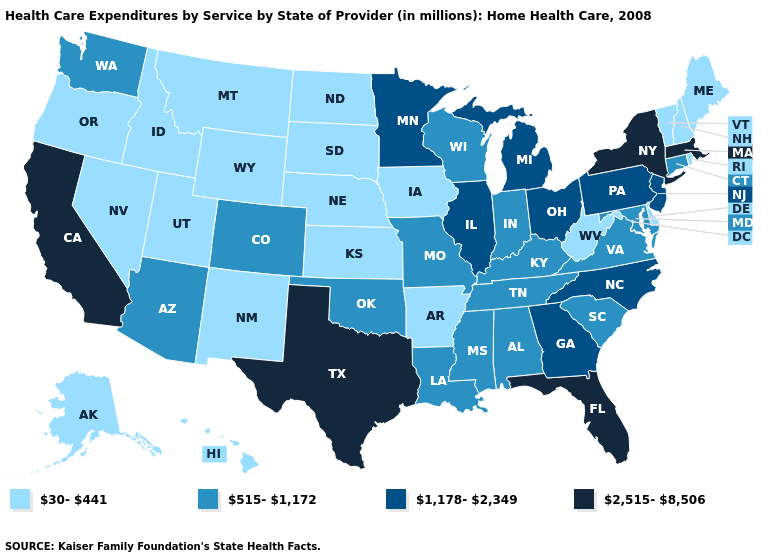Name the states that have a value in the range 515-1,172?
Be succinct. Alabama, Arizona, Colorado, Connecticut, Indiana, Kentucky, Louisiana, Maryland, Mississippi, Missouri, Oklahoma, South Carolina, Tennessee, Virginia, Washington, Wisconsin. Does South Carolina have a lower value than Florida?
Keep it brief. Yes. What is the value of Oregon?
Write a very short answer. 30-441. What is the lowest value in states that border Delaware?
Quick response, please. 515-1,172. Name the states that have a value in the range 30-441?
Short answer required. Alaska, Arkansas, Delaware, Hawaii, Idaho, Iowa, Kansas, Maine, Montana, Nebraska, Nevada, New Hampshire, New Mexico, North Dakota, Oregon, Rhode Island, South Dakota, Utah, Vermont, West Virginia, Wyoming. Among the states that border Wisconsin , which have the lowest value?
Answer briefly. Iowa. Name the states that have a value in the range 30-441?
Concise answer only. Alaska, Arkansas, Delaware, Hawaii, Idaho, Iowa, Kansas, Maine, Montana, Nebraska, Nevada, New Hampshire, New Mexico, North Dakota, Oregon, Rhode Island, South Dakota, Utah, Vermont, West Virginia, Wyoming. Among the states that border Texas , which have the highest value?
Keep it brief. Louisiana, Oklahoma. Among the states that border Rhode Island , which have the highest value?
Short answer required. Massachusetts. Does Pennsylvania have the same value as Ohio?
Concise answer only. Yes. Is the legend a continuous bar?
Quick response, please. No. Does the first symbol in the legend represent the smallest category?
Concise answer only. Yes. Name the states that have a value in the range 1,178-2,349?
Quick response, please. Georgia, Illinois, Michigan, Minnesota, New Jersey, North Carolina, Ohio, Pennsylvania. What is the highest value in the USA?
Concise answer only. 2,515-8,506. What is the value of Tennessee?
Give a very brief answer. 515-1,172. 